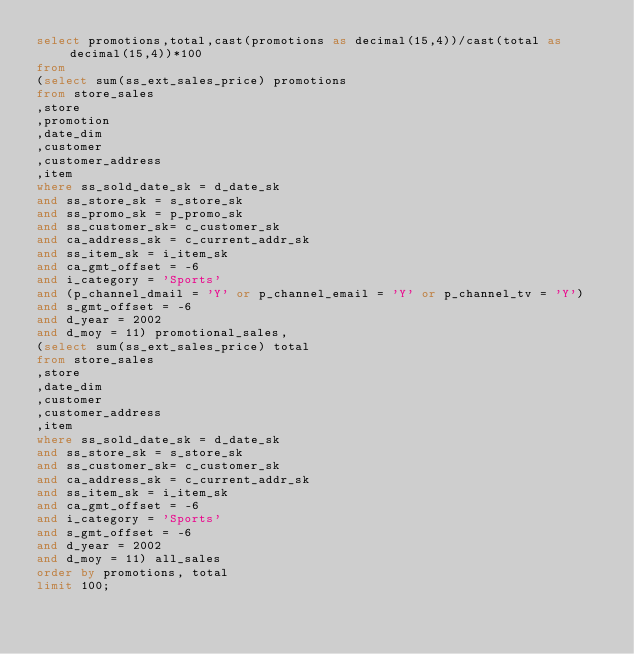<code> <loc_0><loc_0><loc_500><loc_500><_SQL_>select promotions,total,cast(promotions as decimal(15,4))/cast(total as decimal(15,4))*100
from
(select sum(ss_ext_sales_price) promotions
from store_sales
,store
,promotion
,date_dim
,customer
,customer_address
,item
where ss_sold_date_sk = d_date_sk
and ss_store_sk = s_store_sk
and ss_promo_sk = p_promo_sk
and ss_customer_sk= c_customer_sk
and ca_address_sk = c_current_addr_sk
and ss_item_sk = i_item_sk
and ca_gmt_offset = -6
and i_category = 'Sports'
and (p_channel_dmail = 'Y' or p_channel_email = 'Y' or p_channel_tv = 'Y')
and s_gmt_offset = -6
and d_year = 2002
and d_moy = 11) promotional_sales,
(select sum(ss_ext_sales_price) total
from store_sales
,store
,date_dim
,customer
,customer_address
,item
where ss_sold_date_sk = d_date_sk
and ss_store_sk = s_store_sk
and ss_customer_sk= c_customer_sk
and ca_address_sk = c_current_addr_sk
and ss_item_sk = i_item_sk
and ca_gmt_offset = -6
and i_category = 'Sports'
and s_gmt_offset = -6
and d_year = 2002
and d_moy = 11) all_sales
order by promotions, total
limit 100;
</code> 